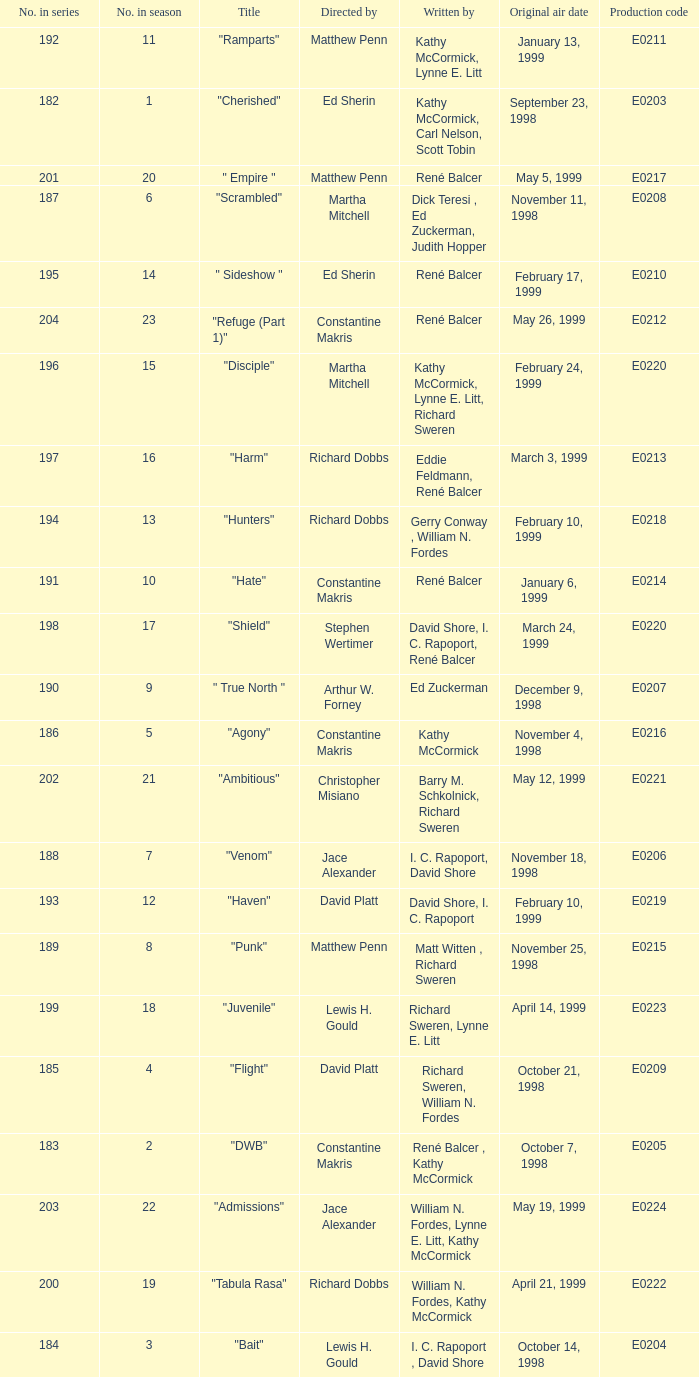The episode with the title "Bait" has what original air date? October 14, 1998. 